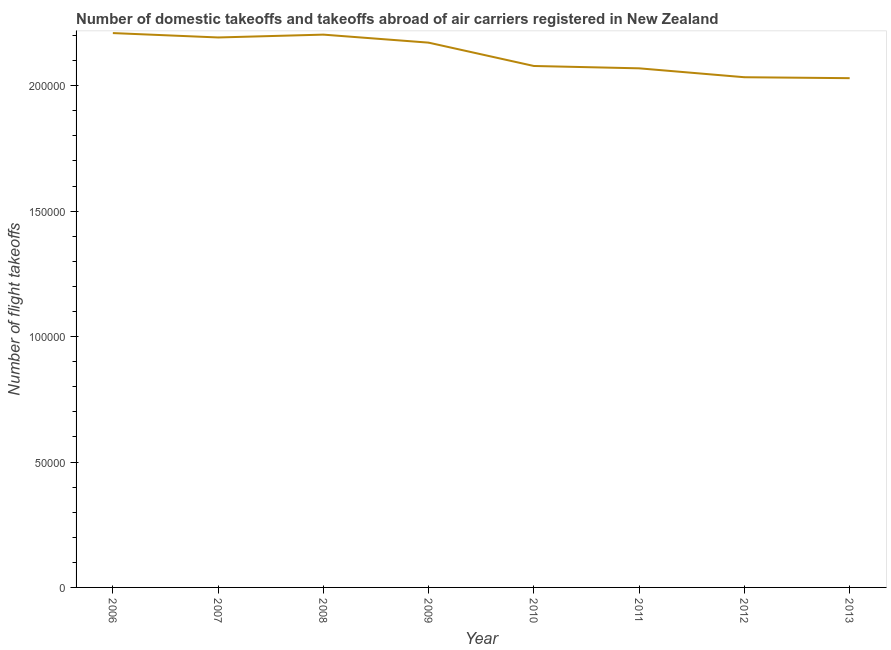What is the number of flight takeoffs in 2010?
Keep it short and to the point. 2.08e+05. Across all years, what is the maximum number of flight takeoffs?
Make the answer very short. 2.21e+05. Across all years, what is the minimum number of flight takeoffs?
Your answer should be very brief. 2.03e+05. In which year was the number of flight takeoffs maximum?
Offer a very short reply. 2006. What is the sum of the number of flight takeoffs?
Provide a succinct answer. 1.70e+06. What is the difference between the number of flight takeoffs in 2010 and 2013?
Your answer should be very brief. 4856.52. What is the average number of flight takeoffs per year?
Offer a terse response. 2.12e+05. What is the median number of flight takeoffs?
Give a very brief answer. 2.13e+05. In how many years, is the number of flight takeoffs greater than 20000 ?
Keep it short and to the point. 8. Do a majority of the years between 2010 and 2008 (inclusive) have number of flight takeoffs greater than 130000 ?
Provide a short and direct response. No. What is the ratio of the number of flight takeoffs in 2006 to that in 2009?
Your answer should be very brief. 1.02. Is the number of flight takeoffs in 2011 less than that in 2012?
Ensure brevity in your answer.  No. Is the difference between the number of flight takeoffs in 2006 and 2012 greater than the difference between any two years?
Your answer should be very brief. No. What is the difference between the highest and the second highest number of flight takeoffs?
Your answer should be very brief. 615. Is the sum of the number of flight takeoffs in 2007 and 2012 greater than the maximum number of flight takeoffs across all years?
Offer a very short reply. Yes. What is the difference between the highest and the lowest number of flight takeoffs?
Offer a very short reply. 1.80e+04. Does the number of flight takeoffs monotonically increase over the years?
Provide a succinct answer. No. What is the difference between two consecutive major ticks on the Y-axis?
Your response must be concise. 5.00e+04. Does the graph contain any zero values?
Provide a succinct answer. No. What is the title of the graph?
Give a very brief answer. Number of domestic takeoffs and takeoffs abroad of air carriers registered in New Zealand. What is the label or title of the X-axis?
Your answer should be compact. Year. What is the label or title of the Y-axis?
Your response must be concise. Number of flight takeoffs. What is the Number of flight takeoffs in 2006?
Your response must be concise. 2.21e+05. What is the Number of flight takeoffs of 2007?
Ensure brevity in your answer.  2.19e+05. What is the Number of flight takeoffs of 2008?
Offer a terse response. 2.20e+05. What is the Number of flight takeoffs in 2009?
Make the answer very short. 2.17e+05. What is the Number of flight takeoffs in 2010?
Your response must be concise. 2.08e+05. What is the Number of flight takeoffs in 2011?
Your answer should be compact. 2.07e+05. What is the Number of flight takeoffs of 2012?
Your answer should be compact. 2.03e+05. What is the Number of flight takeoffs in 2013?
Make the answer very short. 2.03e+05. What is the difference between the Number of flight takeoffs in 2006 and 2007?
Your answer should be compact. 1747. What is the difference between the Number of flight takeoffs in 2006 and 2008?
Offer a very short reply. 615. What is the difference between the Number of flight takeoffs in 2006 and 2009?
Your answer should be compact. 3812. What is the difference between the Number of flight takeoffs in 2006 and 2010?
Your response must be concise. 1.31e+04. What is the difference between the Number of flight takeoffs in 2006 and 2011?
Your response must be concise. 1.41e+04. What is the difference between the Number of flight takeoffs in 2006 and 2012?
Keep it short and to the point. 1.76e+04. What is the difference between the Number of flight takeoffs in 2006 and 2013?
Offer a terse response. 1.80e+04. What is the difference between the Number of flight takeoffs in 2007 and 2008?
Your answer should be very brief. -1132. What is the difference between the Number of flight takeoffs in 2007 and 2009?
Your answer should be compact. 2065. What is the difference between the Number of flight takeoffs in 2007 and 2010?
Keep it short and to the point. 1.14e+04. What is the difference between the Number of flight takeoffs in 2007 and 2011?
Offer a terse response. 1.23e+04. What is the difference between the Number of flight takeoffs in 2007 and 2012?
Make the answer very short. 1.59e+04. What is the difference between the Number of flight takeoffs in 2007 and 2013?
Offer a terse response. 1.62e+04. What is the difference between the Number of flight takeoffs in 2008 and 2009?
Make the answer very short. 3197. What is the difference between the Number of flight takeoffs in 2008 and 2010?
Give a very brief answer. 1.25e+04. What is the difference between the Number of flight takeoffs in 2008 and 2011?
Provide a succinct answer. 1.34e+04. What is the difference between the Number of flight takeoffs in 2008 and 2012?
Offer a terse response. 1.70e+04. What is the difference between the Number of flight takeoffs in 2008 and 2013?
Give a very brief answer. 1.74e+04. What is the difference between the Number of flight takeoffs in 2009 and 2010?
Make the answer very short. 9306. What is the difference between the Number of flight takeoffs in 2009 and 2011?
Keep it short and to the point. 1.02e+04. What is the difference between the Number of flight takeoffs in 2009 and 2012?
Make the answer very short. 1.38e+04. What is the difference between the Number of flight takeoffs in 2009 and 2013?
Ensure brevity in your answer.  1.42e+04. What is the difference between the Number of flight takeoffs in 2010 and 2011?
Offer a terse response. 935. What is the difference between the Number of flight takeoffs in 2010 and 2012?
Provide a succinct answer. 4484. What is the difference between the Number of flight takeoffs in 2010 and 2013?
Offer a terse response. 4856.52. What is the difference between the Number of flight takeoffs in 2011 and 2012?
Offer a very short reply. 3549. What is the difference between the Number of flight takeoffs in 2011 and 2013?
Your response must be concise. 3921.52. What is the difference between the Number of flight takeoffs in 2012 and 2013?
Offer a terse response. 372.52. What is the ratio of the Number of flight takeoffs in 2006 to that in 2008?
Your response must be concise. 1. What is the ratio of the Number of flight takeoffs in 2006 to that in 2009?
Your answer should be compact. 1.02. What is the ratio of the Number of flight takeoffs in 2006 to that in 2010?
Provide a succinct answer. 1.06. What is the ratio of the Number of flight takeoffs in 2006 to that in 2011?
Offer a terse response. 1.07. What is the ratio of the Number of flight takeoffs in 2006 to that in 2012?
Make the answer very short. 1.09. What is the ratio of the Number of flight takeoffs in 2006 to that in 2013?
Your answer should be compact. 1.09. What is the ratio of the Number of flight takeoffs in 2007 to that in 2010?
Your answer should be very brief. 1.05. What is the ratio of the Number of flight takeoffs in 2007 to that in 2011?
Keep it short and to the point. 1.06. What is the ratio of the Number of flight takeoffs in 2007 to that in 2012?
Your response must be concise. 1.08. What is the ratio of the Number of flight takeoffs in 2008 to that in 2009?
Your response must be concise. 1.01. What is the ratio of the Number of flight takeoffs in 2008 to that in 2010?
Provide a short and direct response. 1.06. What is the ratio of the Number of flight takeoffs in 2008 to that in 2011?
Provide a short and direct response. 1.06. What is the ratio of the Number of flight takeoffs in 2008 to that in 2012?
Keep it short and to the point. 1.08. What is the ratio of the Number of flight takeoffs in 2008 to that in 2013?
Offer a very short reply. 1.09. What is the ratio of the Number of flight takeoffs in 2009 to that in 2010?
Offer a terse response. 1.04. What is the ratio of the Number of flight takeoffs in 2009 to that in 2011?
Offer a terse response. 1.05. What is the ratio of the Number of flight takeoffs in 2009 to that in 2012?
Offer a terse response. 1.07. What is the ratio of the Number of flight takeoffs in 2009 to that in 2013?
Provide a short and direct response. 1.07. What is the ratio of the Number of flight takeoffs in 2010 to that in 2012?
Your response must be concise. 1.02. What is the ratio of the Number of flight takeoffs in 2010 to that in 2013?
Offer a very short reply. 1.02. What is the ratio of the Number of flight takeoffs in 2011 to that in 2012?
Offer a terse response. 1.02. What is the ratio of the Number of flight takeoffs in 2011 to that in 2013?
Give a very brief answer. 1.02. What is the ratio of the Number of flight takeoffs in 2012 to that in 2013?
Provide a short and direct response. 1. 